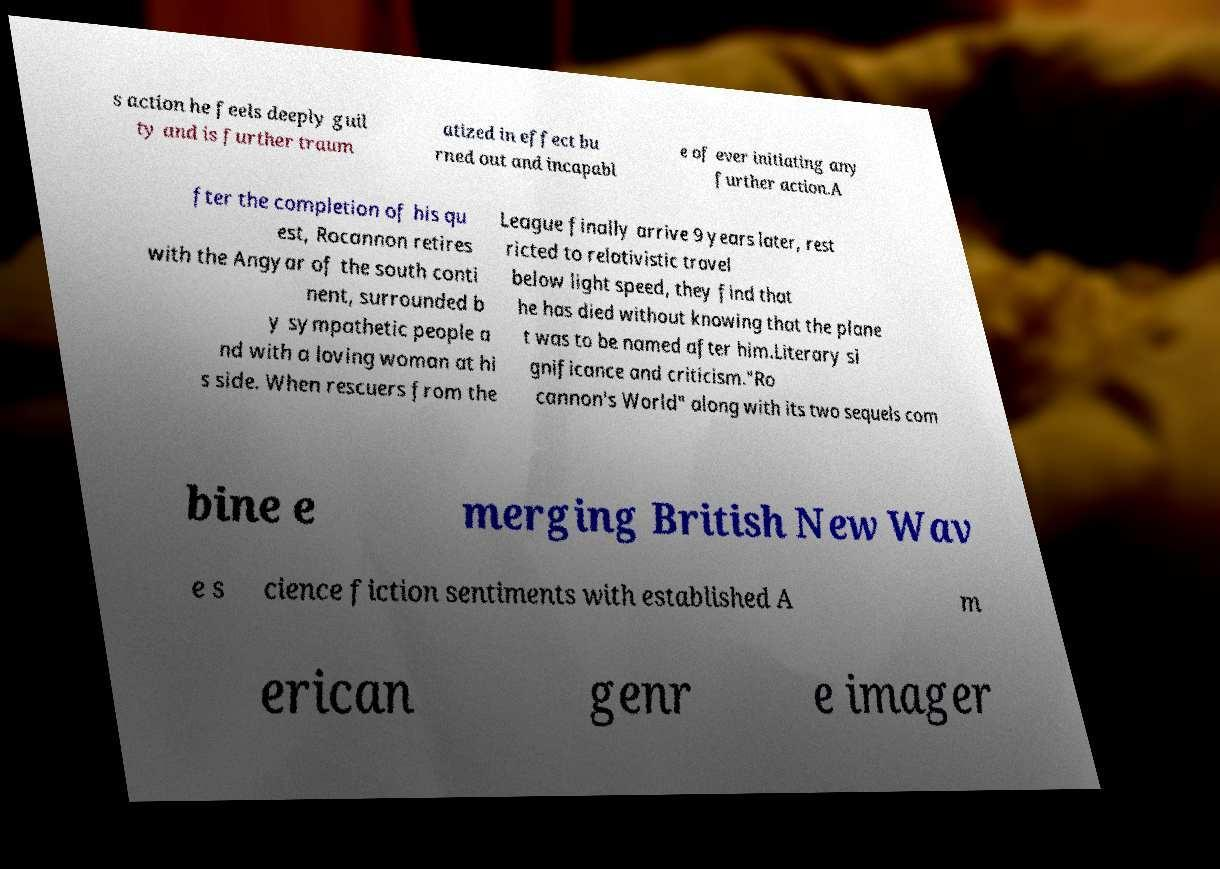Can you accurately transcribe the text from the provided image for me? s action he feels deeply guil ty and is further traum atized in effect bu rned out and incapabl e of ever initiating any further action.A fter the completion of his qu est, Rocannon retires with the Angyar of the south conti nent, surrounded b y sympathetic people a nd with a loving woman at hi s side. When rescuers from the League finally arrive 9 years later, rest ricted to relativistic travel below light speed, they find that he has died without knowing that the plane t was to be named after him.Literary si gnificance and criticism."Ro cannon's World" along with its two sequels com bine e merging British New Wav e s cience fiction sentiments with established A m erican genr e imager 